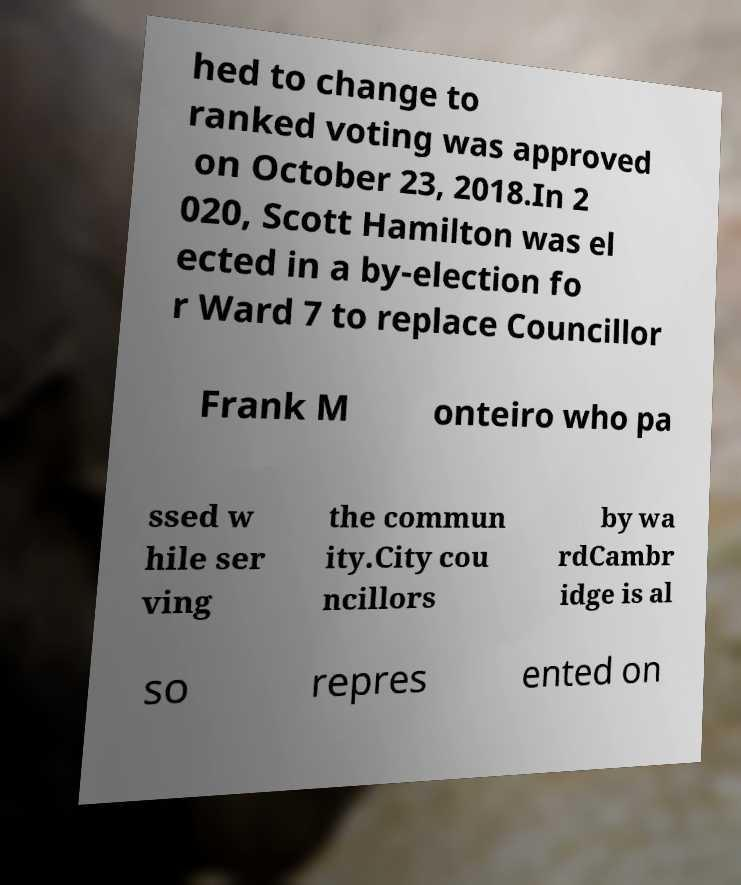For documentation purposes, I need the text within this image transcribed. Could you provide that? hed to change to ranked voting was approved on October 23, 2018.In 2 020, Scott Hamilton was el ected in a by-election fo r Ward 7 to replace Councillor Frank M onteiro who pa ssed w hile ser ving the commun ity.City cou ncillors by wa rdCambr idge is al so repres ented on 